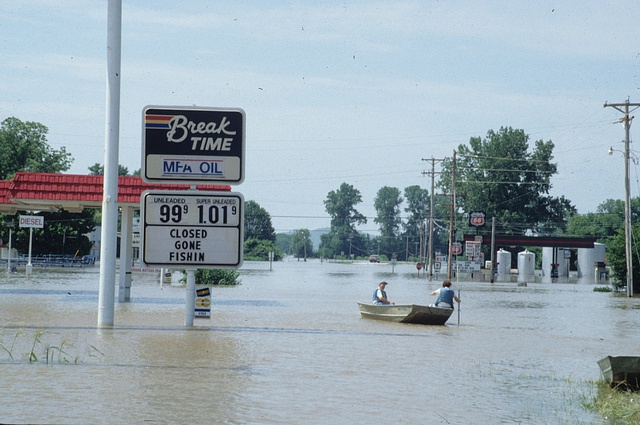Describe the objects in this image and their specific colors. I can see boat in lightblue, gray, black, and darkgray tones, boat in lightblue, black, gray, and darkgreen tones, people in lightblue, blue, navy, gray, and darkgray tones, and people in lightblue, gray, lightgray, and darkgray tones in this image. 